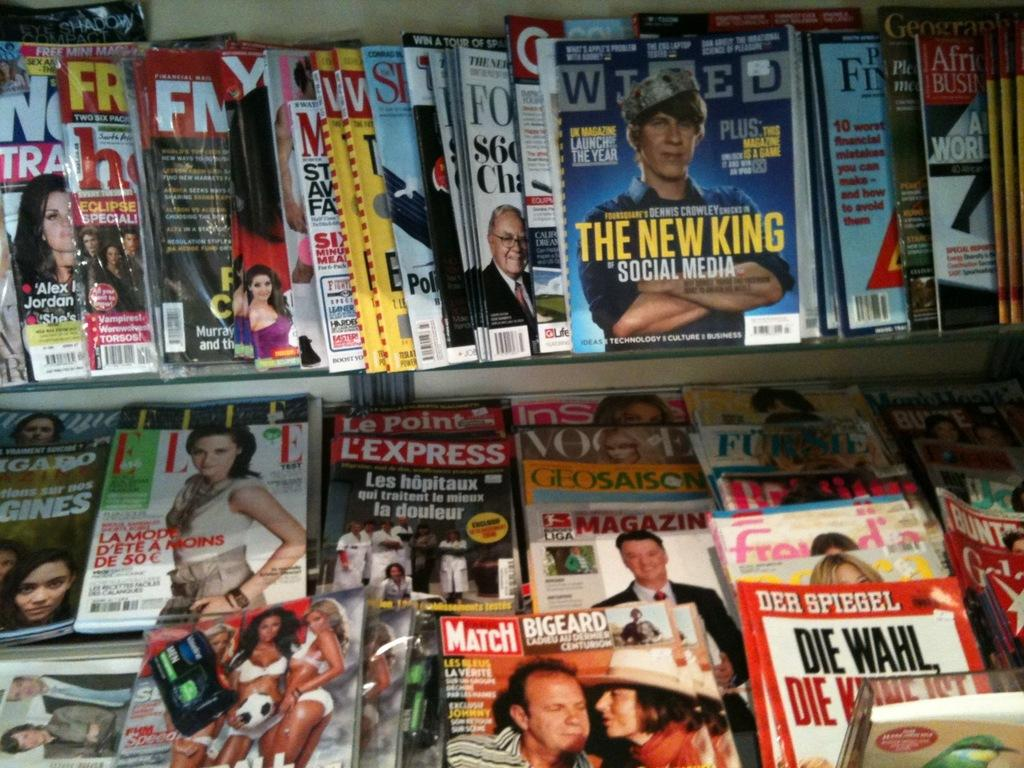<image>
Write a terse but informative summary of the picture. a bunch of magazine like Wired and Paris Match on display 